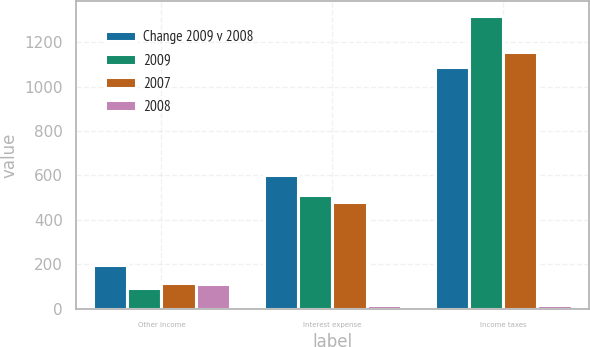<chart> <loc_0><loc_0><loc_500><loc_500><stacked_bar_chart><ecel><fcel>Other income<fcel>Interest expense<fcel>Income taxes<nl><fcel>Change 2009 v 2008<fcel>195<fcel>600<fcel>1089<nl><fcel>2009<fcel>92<fcel>511<fcel>1318<nl><fcel>2007<fcel>116<fcel>482<fcel>1154<nl><fcel>2008<fcel>112<fcel>17<fcel>17<nl></chart> 